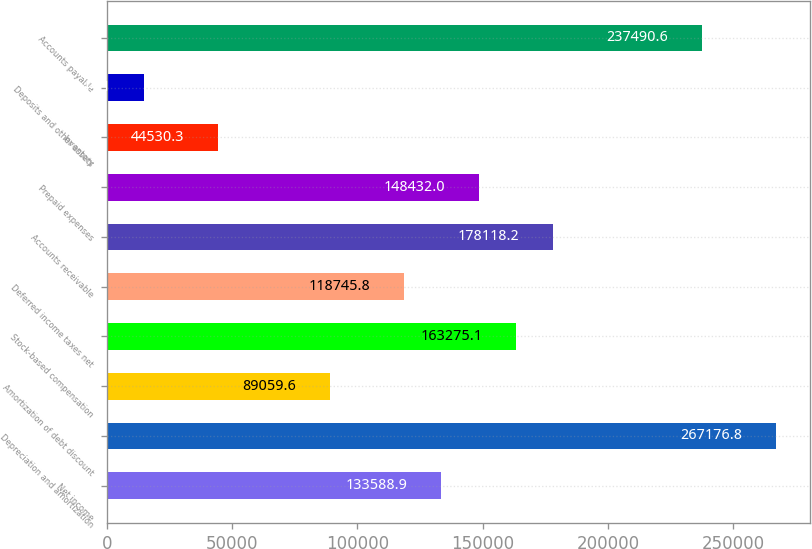Convert chart to OTSL. <chart><loc_0><loc_0><loc_500><loc_500><bar_chart><fcel>Net income<fcel>Depreciation and amortization<fcel>Amortization of debt discount<fcel>Stock-based compensation<fcel>Deferred income taxes net<fcel>Accounts receivable<fcel>Prepaid expenses<fcel>Inventory<fcel>Deposits and other assets<fcel>Accounts payable<nl><fcel>133589<fcel>267177<fcel>89059.6<fcel>163275<fcel>118746<fcel>178118<fcel>148432<fcel>44530.3<fcel>14844.1<fcel>237491<nl></chart> 